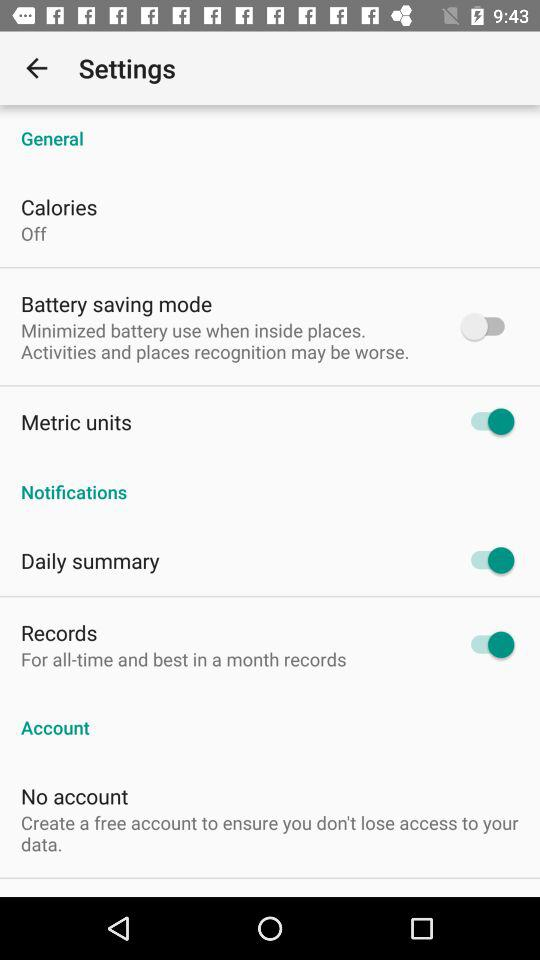What is the status of "Metric units"? The status is "on". 